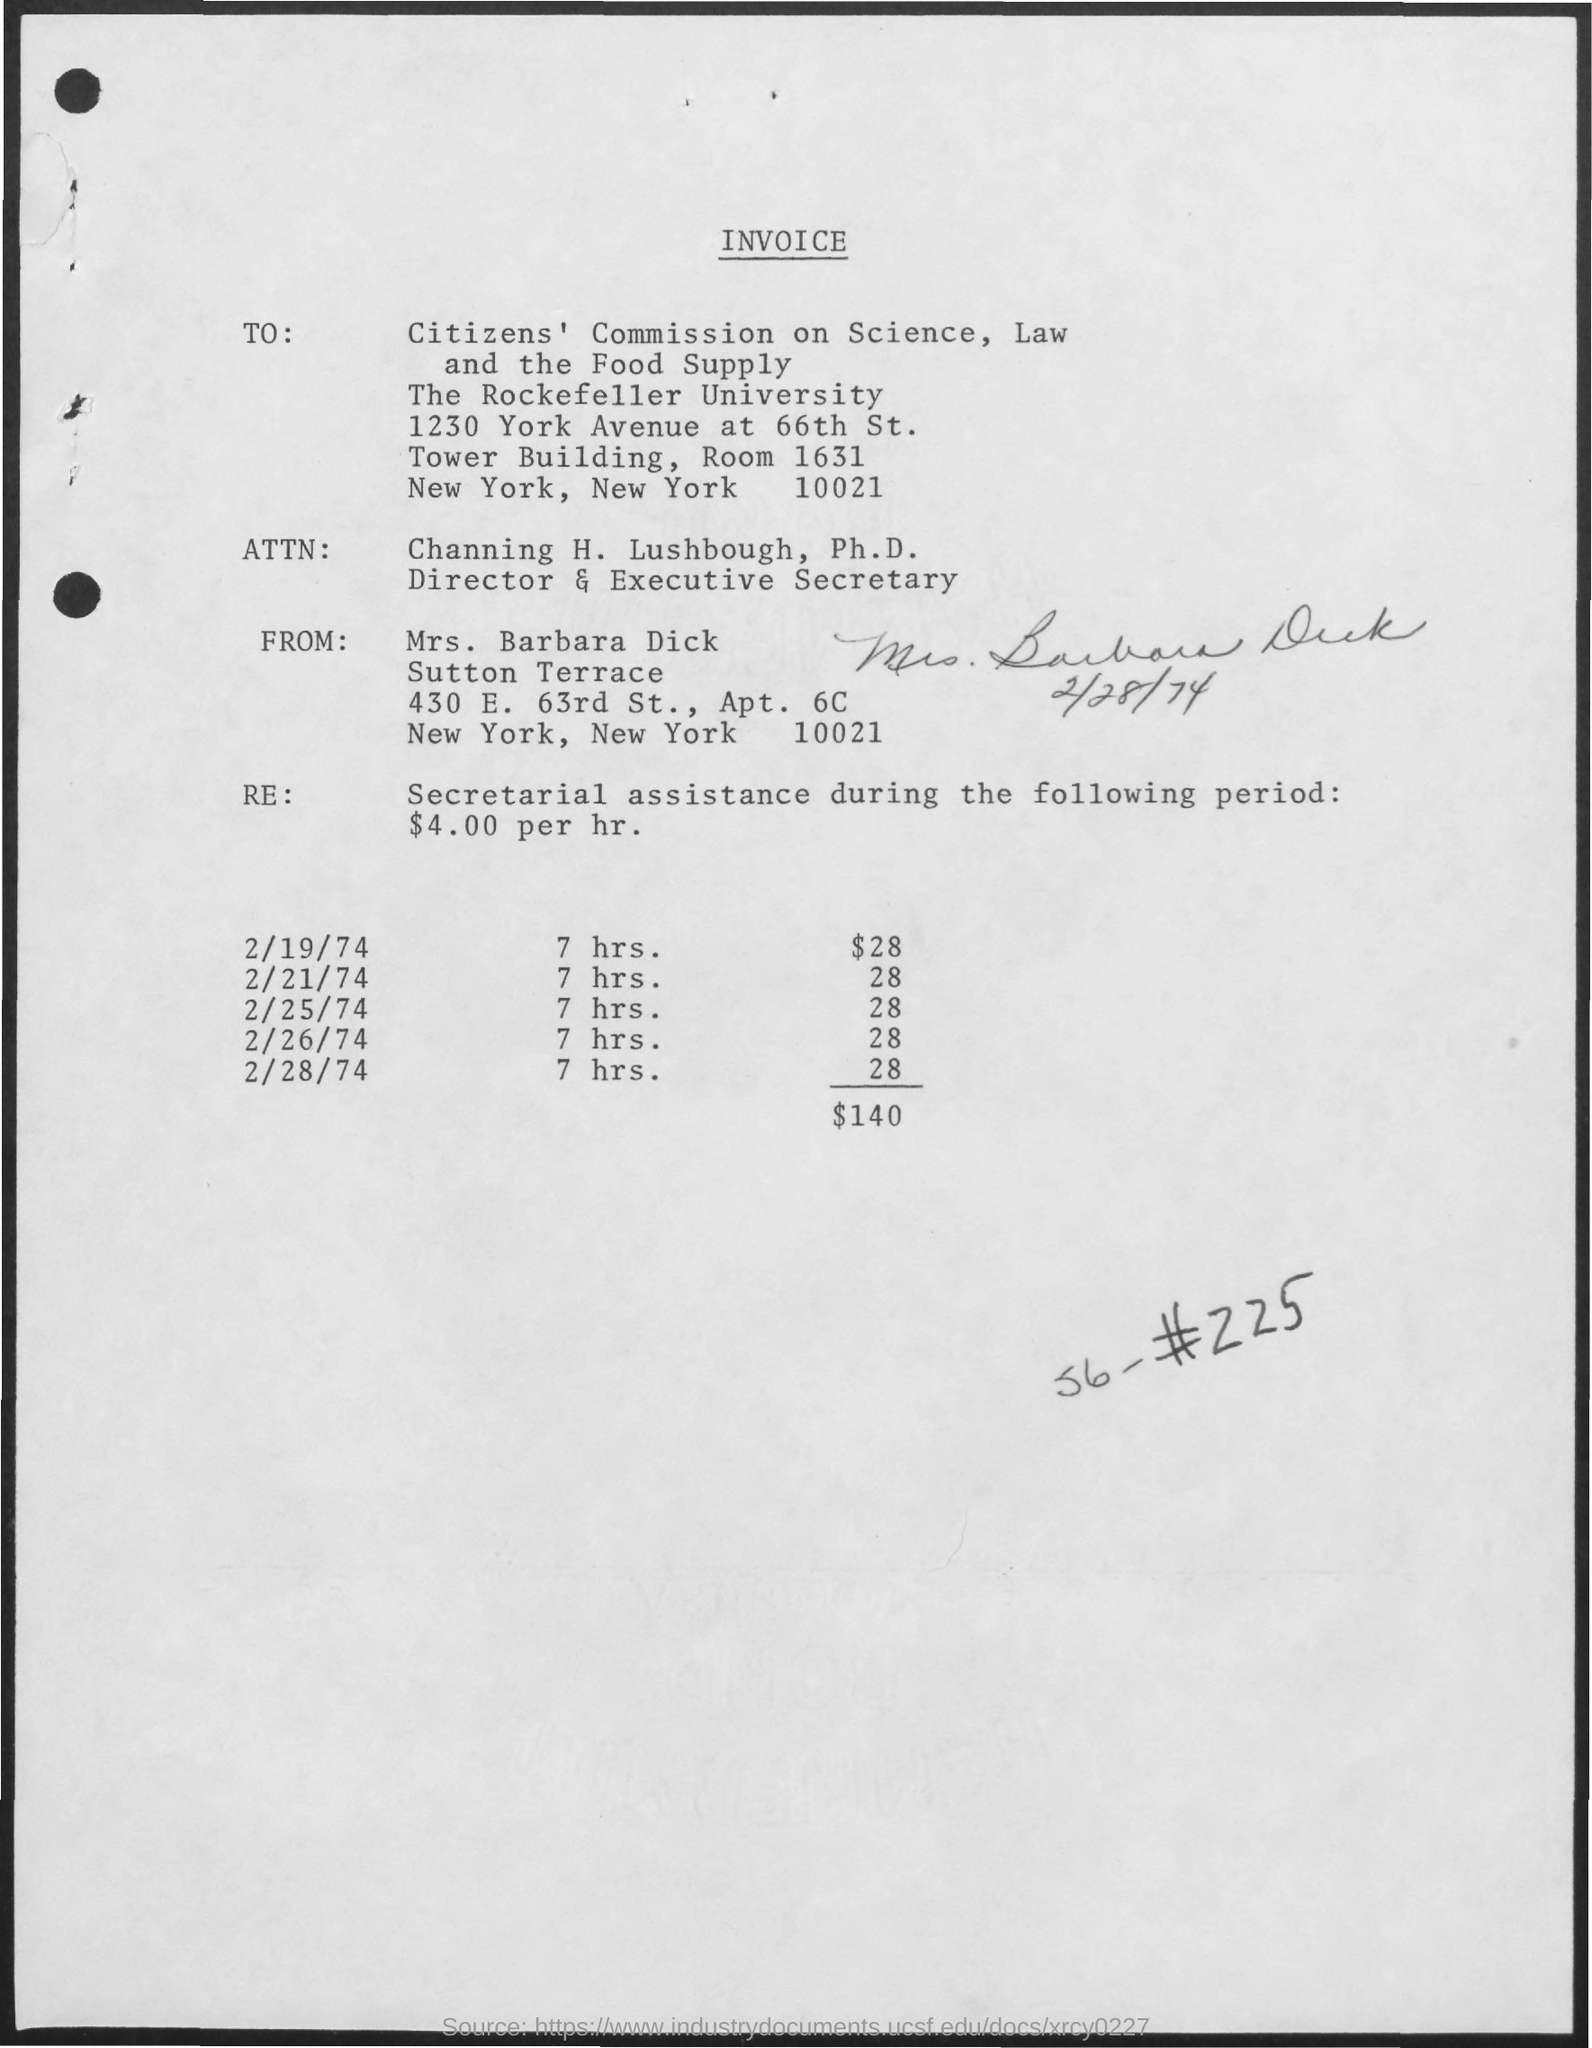from whom the invoice is delivered ? The invoice is delivered by Mrs. Barbara Dick from Sutton Terrace, 430 E. 63rd St., Apt. 6C, New York, NY 10021, as indicated in the 'From' section of the invoice. 